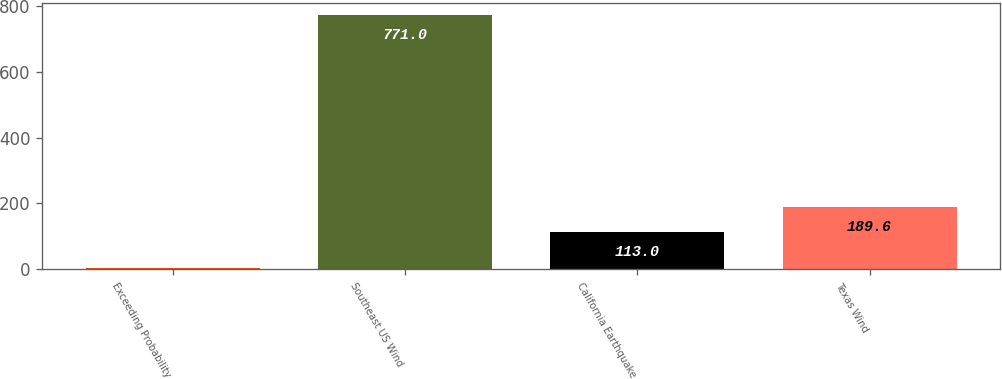Convert chart. <chart><loc_0><loc_0><loc_500><loc_500><bar_chart><fcel>Exceeding Probability<fcel>Southeast US Wind<fcel>California Earthquake<fcel>Texas Wind<nl><fcel>5<fcel>771<fcel>113<fcel>189.6<nl></chart> 